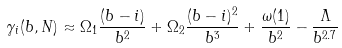<formula> <loc_0><loc_0><loc_500><loc_500>\gamma _ { i } ( b , N ) \approx \Omega _ { 1 } \frac { ( b - i ) } { b ^ { 2 } } + \Omega _ { 2 } \frac { ( b - i ) ^ { 2 } } { b ^ { 3 } } + \frac { \omega ( 1 ) } { b ^ { 2 } } - \frac { \Lambda } { b ^ { 2 . 7 } }</formula> 